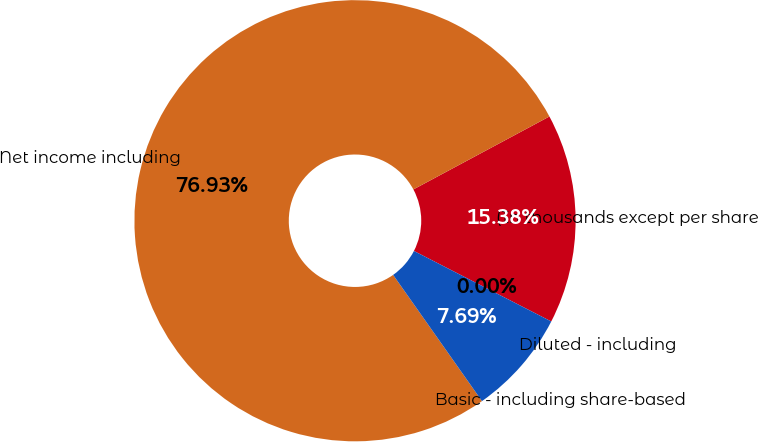<chart> <loc_0><loc_0><loc_500><loc_500><pie_chart><fcel>(In thousands except per share<fcel>Net income including<fcel>Basic - including share-based<fcel>Diluted - including<nl><fcel>15.38%<fcel>76.92%<fcel>7.69%<fcel>0.0%<nl></chart> 